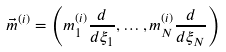<formula> <loc_0><loc_0><loc_500><loc_500>\vec { m } ^ { ( i ) } = \left ( m _ { 1 } ^ { ( i ) } \frac { d } { d \xi _ { 1 } } , \dots , m _ { N } ^ { ( i ) } \frac { d } { d \xi _ { N } } \right )</formula> 